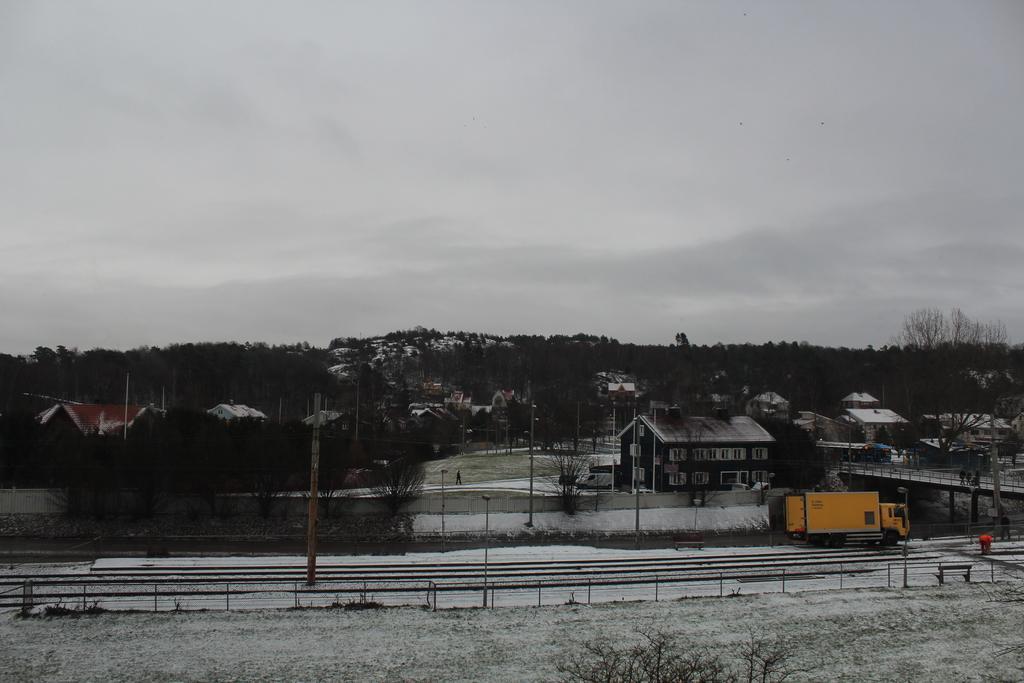Please provide a concise description of this image. In this image, I can see the houses and the trees. This looks like a truck on the road. I think this is a pole. This looks like a bench. This is the sky. I think this is the snow. 